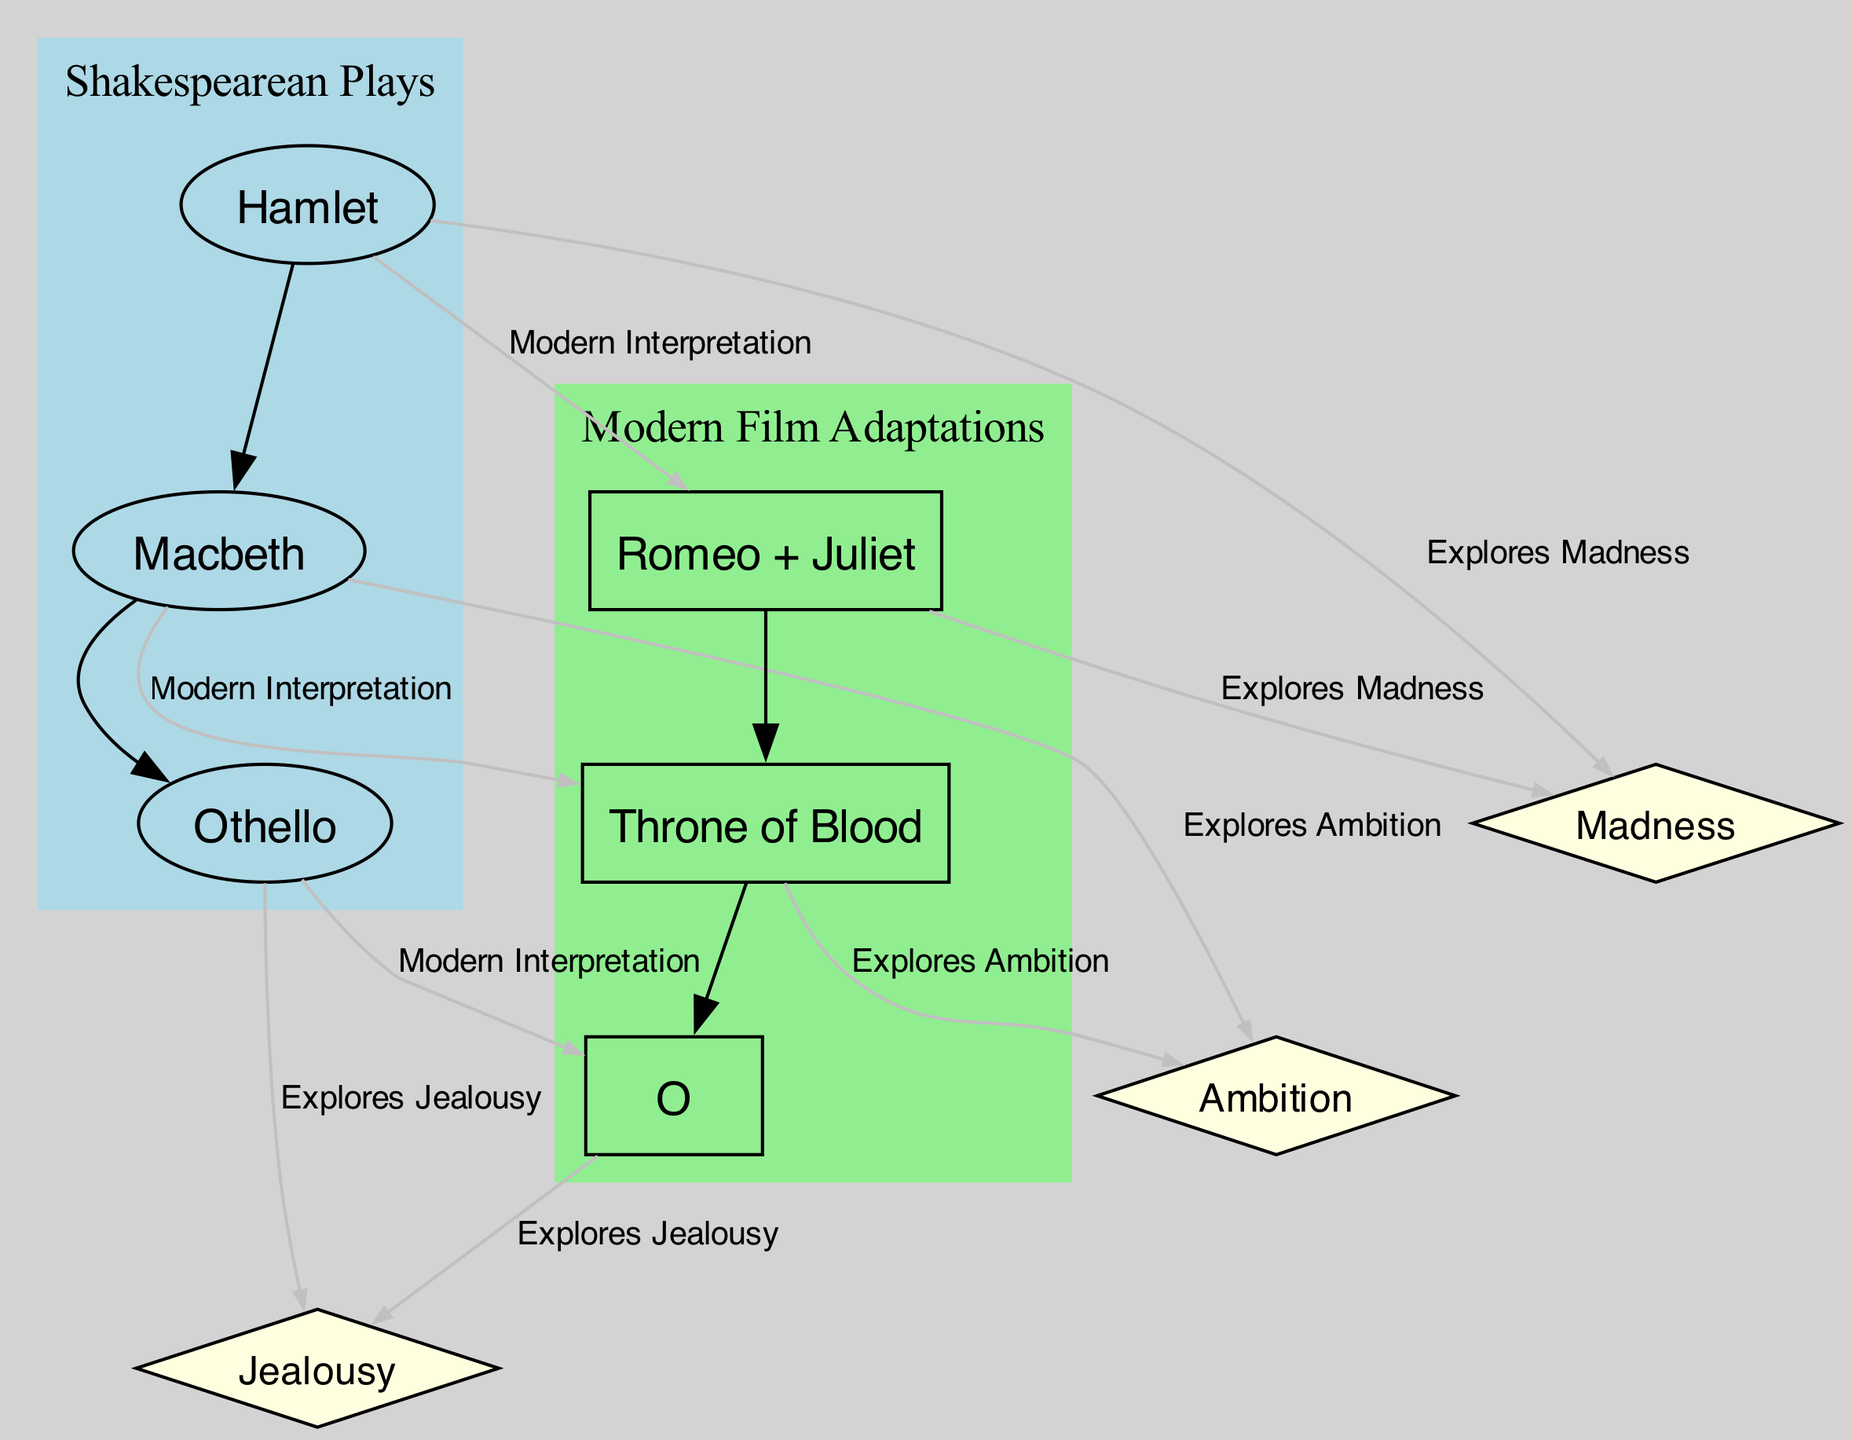What are the three Shakespearean plays depicted in the diagram? The diagram includes three nodes labeled as Shakespearean Plays: Hamlet, Macbeth, and Othello. These labels provide direct evidence of the plays featured.
Answer: Hamlet, Macbeth, Othello How many modern film adaptations are represented in the diagram? There are three nodes labeled as Modern Film Adaptations: Romeo + Juliet, Throne of Blood, and O. Counting these nodes gives the total number of adaptations represented.
Answer: 3 What theme is explored by both Hamlet and Rome + Juliet? The diagram shows that both Hamlet and Romeo + Juliet are connected to the theme of Madness, indicated by the direct edges linking these nodes.
Answer: Madness Which Shakespearean play is associated with the theme of Jealousy? In the diagram, the node for Othello is linked to the theme of Jealousy, indicated by an edge. Thus, Othello is the play associated with this theme.
Answer: Othello Which modern film adaptation explores the theme of Ambition? The node Throne of Blood shows a direct connection to the theme of Ambition in the diagram, which indicates this film's focus on that theme.
Answer: Throne of Blood What type of connection exists between Macbeth and its modern adaptation? The diagram illustrates that there is a "Modern Interpretation" connection between Macbeth and Throne of Blood, which describes the nature of their relationship.
Answer: Modern Interpretation How many total edges connect Shakespearean plays to their corresponding modern adaptations? By counting the edges in the diagram that link the Shakespearean plays to their modern adaptations, there are three direct edges indicating these connections.
Answer: 3 Which theme do the modern adaptations O and Romeo + Juliet explore? The diagram shows that O explores Jealousy, while Romeo + Juliet explores Madness, showing a thematic commonality in their exploration of human emotions.
Answer: Jealousy and Madness 